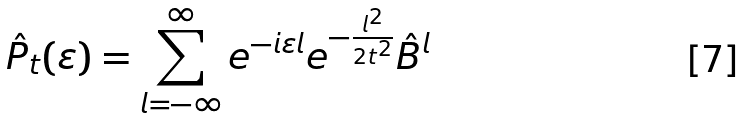Convert formula to latex. <formula><loc_0><loc_0><loc_500><loc_500>\hat { P } _ { t } ( \varepsilon ) = \sum _ { l = - \infty } ^ { \infty } e ^ { - i \varepsilon l } e ^ { - \frac { l ^ { 2 } } { 2 t ^ { 2 } } } \hat { B } ^ { l }</formula> 